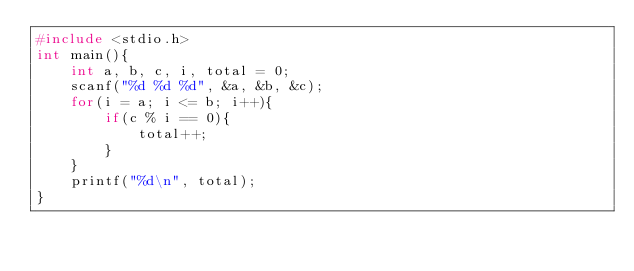<code> <loc_0><loc_0><loc_500><loc_500><_C_>#include <stdio.h>
int main(){
    int a, b, c, i, total = 0;
    scanf("%d %d %d", &a, &b, &c);
    for(i = a; i <= b; i++){
        if(c % i == 0){
            total++;
        }
    }
    printf("%d\n", total);
}</code> 